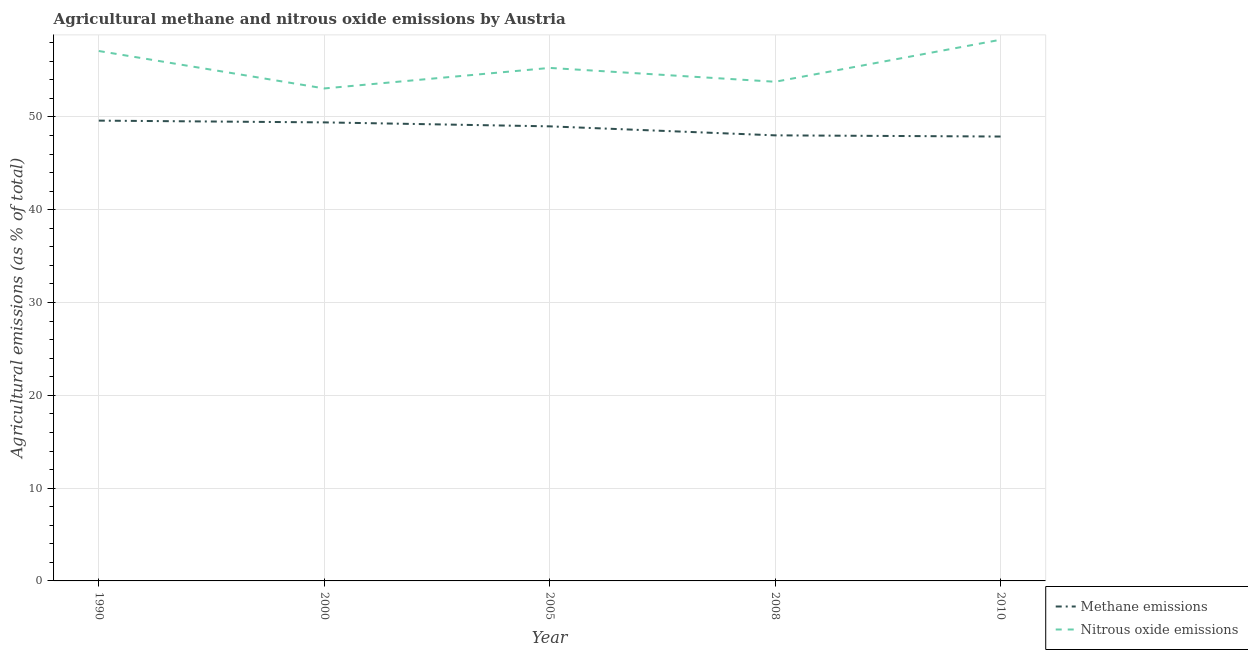How many different coloured lines are there?
Offer a terse response. 2. Does the line corresponding to amount of nitrous oxide emissions intersect with the line corresponding to amount of methane emissions?
Offer a terse response. No. Is the number of lines equal to the number of legend labels?
Make the answer very short. Yes. What is the amount of nitrous oxide emissions in 2008?
Offer a very short reply. 53.8. Across all years, what is the maximum amount of methane emissions?
Your answer should be very brief. 49.61. Across all years, what is the minimum amount of methane emissions?
Provide a succinct answer. 47.89. In which year was the amount of methane emissions maximum?
Keep it short and to the point. 1990. In which year was the amount of methane emissions minimum?
Ensure brevity in your answer.  2010. What is the total amount of methane emissions in the graph?
Provide a short and direct response. 243.92. What is the difference between the amount of nitrous oxide emissions in 1990 and that in 2000?
Keep it short and to the point. 4.04. What is the difference between the amount of nitrous oxide emissions in 2008 and the amount of methane emissions in 2010?
Offer a very short reply. 5.9. What is the average amount of nitrous oxide emissions per year?
Give a very brief answer. 55.52. In the year 2010, what is the difference between the amount of nitrous oxide emissions and amount of methane emissions?
Your answer should be very brief. 10.43. What is the ratio of the amount of nitrous oxide emissions in 2000 to that in 2010?
Your response must be concise. 0.91. Is the amount of methane emissions in 2000 less than that in 2008?
Offer a very short reply. No. What is the difference between the highest and the second highest amount of nitrous oxide emissions?
Provide a succinct answer. 1.22. What is the difference between the highest and the lowest amount of nitrous oxide emissions?
Make the answer very short. 5.25. In how many years, is the amount of nitrous oxide emissions greater than the average amount of nitrous oxide emissions taken over all years?
Offer a terse response. 2. Is the sum of the amount of nitrous oxide emissions in 1990 and 2008 greater than the maximum amount of methane emissions across all years?
Provide a succinct answer. Yes. How many lines are there?
Offer a very short reply. 2. What is the difference between two consecutive major ticks on the Y-axis?
Make the answer very short. 10. Are the values on the major ticks of Y-axis written in scientific E-notation?
Provide a succinct answer. No. How many legend labels are there?
Provide a short and direct response. 2. What is the title of the graph?
Provide a succinct answer. Agricultural methane and nitrous oxide emissions by Austria. Does "Goods" appear as one of the legend labels in the graph?
Offer a terse response. No. What is the label or title of the Y-axis?
Give a very brief answer. Agricultural emissions (as % of total). What is the Agricultural emissions (as % of total) of Methane emissions in 1990?
Provide a succinct answer. 49.61. What is the Agricultural emissions (as % of total) of Nitrous oxide emissions in 1990?
Ensure brevity in your answer.  57.11. What is the Agricultural emissions (as % of total) in Methane emissions in 2000?
Provide a succinct answer. 49.42. What is the Agricultural emissions (as % of total) of Nitrous oxide emissions in 2000?
Offer a terse response. 53.07. What is the Agricultural emissions (as % of total) of Methane emissions in 2005?
Your answer should be very brief. 48.99. What is the Agricultural emissions (as % of total) of Nitrous oxide emissions in 2005?
Offer a very short reply. 55.29. What is the Agricultural emissions (as % of total) of Methane emissions in 2008?
Offer a terse response. 48.02. What is the Agricultural emissions (as % of total) of Nitrous oxide emissions in 2008?
Your response must be concise. 53.8. What is the Agricultural emissions (as % of total) of Methane emissions in 2010?
Provide a short and direct response. 47.89. What is the Agricultural emissions (as % of total) in Nitrous oxide emissions in 2010?
Offer a very short reply. 58.33. Across all years, what is the maximum Agricultural emissions (as % of total) of Methane emissions?
Your answer should be very brief. 49.61. Across all years, what is the maximum Agricultural emissions (as % of total) in Nitrous oxide emissions?
Your answer should be compact. 58.33. Across all years, what is the minimum Agricultural emissions (as % of total) of Methane emissions?
Your response must be concise. 47.89. Across all years, what is the minimum Agricultural emissions (as % of total) in Nitrous oxide emissions?
Your answer should be very brief. 53.07. What is the total Agricultural emissions (as % of total) of Methane emissions in the graph?
Ensure brevity in your answer.  243.92. What is the total Agricultural emissions (as % of total) of Nitrous oxide emissions in the graph?
Make the answer very short. 277.59. What is the difference between the Agricultural emissions (as % of total) of Methane emissions in 1990 and that in 2000?
Keep it short and to the point. 0.19. What is the difference between the Agricultural emissions (as % of total) of Nitrous oxide emissions in 1990 and that in 2000?
Give a very brief answer. 4.04. What is the difference between the Agricultural emissions (as % of total) of Methane emissions in 1990 and that in 2005?
Offer a very short reply. 0.62. What is the difference between the Agricultural emissions (as % of total) in Nitrous oxide emissions in 1990 and that in 2005?
Offer a terse response. 1.82. What is the difference between the Agricultural emissions (as % of total) in Methane emissions in 1990 and that in 2008?
Give a very brief answer. 1.59. What is the difference between the Agricultural emissions (as % of total) in Nitrous oxide emissions in 1990 and that in 2008?
Make the answer very short. 3.32. What is the difference between the Agricultural emissions (as % of total) in Methane emissions in 1990 and that in 2010?
Provide a succinct answer. 1.71. What is the difference between the Agricultural emissions (as % of total) in Nitrous oxide emissions in 1990 and that in 2010?
Your response must be concise. -1.22. What is the difference between the Agricultural emissions (as % of total) of Methane emissions in 2000 and that in 2005?
Keep it short and to the point. 0.43. What is the difference between the Agricultural emissions (as % of total) in Nitrous oxide emissions in 2000 and that in 2005?
Ensure brevity in your answer.  -2.21. What is the difference between the Agricultural emissions (as % of total) in Methane emissions in 2000 and that in 2008?
Give a very brief answer. 1.4. What is the difference between the Agricultural emissions (as % of total) of Nitrous oxide emissions in 2000 and that in 2008?
Your answer should be very brief. -0.72. What is the difference between the Agricultural emissions (as % of total) in Methane emissions in 2000 and that in 2010?
Offer a terse response. 1.53. What is the difference between the Agricultural emissions (as % of total) in Nitrous oxide emissions in 2000 and that in 2010?
Offer a terse response. -5.25. What is the difference between the Agricultural emissions (as % of total) of Methane emissions in 2005 and that in 2008?
Your response must be concise. 0.97. What is the difference between the Agricultural emissions (as % of total) in Nitrous oxide emissions in 2005 and that in 2008?
Offer a very short reply. 1.49. What is the difference between the Agricultural emissions (as % of total) of Methane emissions in 2005 and that in 2010?
Offer a very short reply. 1.1. What is the difference between the Agricultural emissions (as % of total) in Nitrous oxide emissions in 2005 and that in 2010?
Your response must be concise. -3.04. What is the difference between the Agricultural emissions (as % of total) of Methane emissions in 2008 and that in 2010?
Your answer should be very brief. 0.13. What is the difference between the Agricultural emissions (as % of total) in Nitrous oxide emissions in 2008 and that in 2010?
Provide a short and direct response. -4.53. What is the difference between the Agricultural emissions (as % of total) in Methane emissions in 1990 and the Agricultural emissions (as % of total) in Nitrous oxide emissions in 2000?
Provide a short and direct response. -3.47. What is the difference between the Agricultural emissions (as % of total) in Methane emissions in 1990 and the Agricultural emissions (as % of total) in Nitrous oxide emissions in 2005?
Provide a short and direct response. -5.68. What is the difference between the Agricultural emissions (as % of total) of Methane emissions in 1990 and the Agricultural emissions (as % of total) of Nitrous oxide emissions in 2008?
Keep it short and to the point. -4.19. What is the difference between the Agricultural emissions (as % of total) of Methane emissions in 1990 and the Agricultural emissions (as % of total) of Nitrous oxide emissions in 2010?
Your answer should be compact. -8.72. What is the difference between the Agricultural emissions (as % of total) of Methane emissions in 2000 and the Agricultural emissions (as % of total) of Nitrous oxide emissions in 2005?
Make the answer very short. -5.87. What is the difference between the Agricultural emissions (as % of total) of Methane emissions in 2000 and the Agricultural emissions (as % of total) of Nitrous oxide emissions in 2008?
Your answer should be compact. -4.38. What is the difference between the Agricultural emissions (as % of total) in Methane emissions in 2000 and the Agricultural emissions (as % of total) in Nitrous oxide emissions in 2010?
Your answer should be very brief. -8.91. What is the difference between the Agricultural emissions (as % of total) in Methane emissions in 2005 and the Agricultural emissions (as % of total) in Nitrous oxide emissions in 2008?
Provide a short and direct response. -4.81. What is the difference between the Agricultural emissions (as % of total) of Methane emissions in 2005 and the Agricultural emissions (as % of total) of Nitrous oxide emissions in 2010?
Keep it short and to the point. -9.34. What is the difference between the Agricultural emissions (as % of total) in Methane emissions in 2008 and the Agricultural emissions (as % of total) in Nitrous oxide emissions in 2010?
Offer a very short reply. -10.31. What is the average Agricultural emissions (as % of total) in Methane emissions per year?
Provide a succinct answer. 48.78. What is the average Agricultural emissions (as % of total) of Nitrous oxide emissions per year?
Ensure brevity in your answer.  55.52. In the year 1990, what is the difference between the Agricultural emissions (as % of total) of Methane emissions and Agricultural emissions (as % of total) of Nitrous oxide emissions?
Ensure brevity in your answer.  -7.5. In the year 2000, what is the difference between the Agricultural emissions (as % of total) of Methane emissions and Agricultural emissions (as % of total) of Nitrous oxide emissions?
Make the answer very short. -3.66. In the year 2005, what is the difference between the Agricultural emissions (as % of total) in Methane emissions and Agricultural emissions (as % of total) in Nitrous oxide emissions?
Provide a short and direct response. -6.3. In the year 2008, what is the difference between the Agricultural emissions (as % of total) of Methane emissions and Agricultural emissions (as % of total) of Nitrous oxide emissions?
Your response must be concise. -5.78. In the year 2010, what is the difference between the Agricultural emissions (as % of total) in Methane emissions and Agricultural emissions (as % of total) in Nitrous oxide emissions?
Offer a terse response. -10.43. What is the ratio of the Agricultural emissions (as % of total) of Methane emissions in 1990 to that in 2000?
Offer a very short reply. 1. What is the ratio of the Agricultural emissions (as % of total) of Nitrous oxide emissions in 1990 to that in 2000?
Keep it short and to the point. 1.08. What is the ratio of the Agricultural emissions (as % of total) of Methane emissions in 1990 to that in 2005?
Offer a very short reply. 1.01. What is the ratio of the Agricultural emissions (as % of total) of Nitrous oxide emissions in 1990 to that in 2005?
Your answer should be very brief. 1.03. What is the ratio of the Agricultural emissions (as % of total) in Methane emissions in 1990 to that in 2008?
Provide a short and direct response. 1.03. What is the ratio of the Agricultural emissions (as % of total) in Nitrous oxide emissions in 1990 to that in 2008?
Your answer should be very brief. 1.06. What is the ratio of the Agricultural emissions (as % of total) in Methane emissions in 1990 to that in 2010?
Provide a short and direct response. 1.04. What is the ratio of the Agricultural emissions (as % of total) of Nitrous oxide emissions in 1990 to that in 2010?
Make the answer very short. 0.98. What is the ratio of the Agricultural emissions (as % of total) of Methane emissions in 2000 to that in 2005?
Your response must be concise. 1.01. What is the ratio of the Agricultural emissions (as % of total) in Methane emissions in 2000 to that in 2008?
Provide a short and direct response. 1.03. What is the ratio of the Agricultural emissions (as % of total) in Nitrous oxide emissions in 2000 to that in 2008?
Your answer should be very brief. 0.99. What is the ratio of the Agricultural emissions (as % of total) in Methane emissions in 2000 to that in 2010?
Ensure brevity in your answer.  1.03. What is the ratio of the Agricultural emissions (as % of total) of Nitrous oxide emissions in 2000 to that in 2010?
Offer a very short reply. 0.91. What is the ratio of the Agricultural emissions (as % of total) in Methane emissions in 2005 to that in 2008?
Give a very brief answer. 1.02. What is the ratio of the Agricultural emissions (as % of total) in Nitrous oxide emissions in 2005 to that in 2008?
Make the answer very short. 1.03. What is the ratio of the Agricultural emissions (as % of total) of Methane emissions in 2005 to that in 2010?
Provide a short and direct response. 1.02. What is the ratio of the Agricultural emissions (as % of total) in Nitrous oxide emissions in 2005 to that in 2010?
Provide a short and direct response. 0.95. What is the ratio of the Agricultural emissions (as % of total) of Methane emissions in 2008 to that in 2010?
Provide a short and direct response. 1. What is the ratio of the Agricultural emissions (as % of total) of Nitrous oxide emissions in 2008 to that in 2010?
Provide a short and direct response. 0.92. What is the difference between the highest and the second highest Agricultural emissions (as % of total) of Methane emissions?
Ensure brevity in your answer.  0.19. What is the difference between the highest and the second highest Agricultural emissions (as % of total) in Nitrous oxide emissions?
Offer a very short reply. 1.22. What is the difference between the highest and the lowest Agricultural emissions (as % of total) of Methane emissions?
Ensure brevity in your answer.  1.71. What is the difference between the highest and the lowest Agricultural emissions (as % of total) in Nitrous oxide emissions?
Offer a terse response. 5.25. 